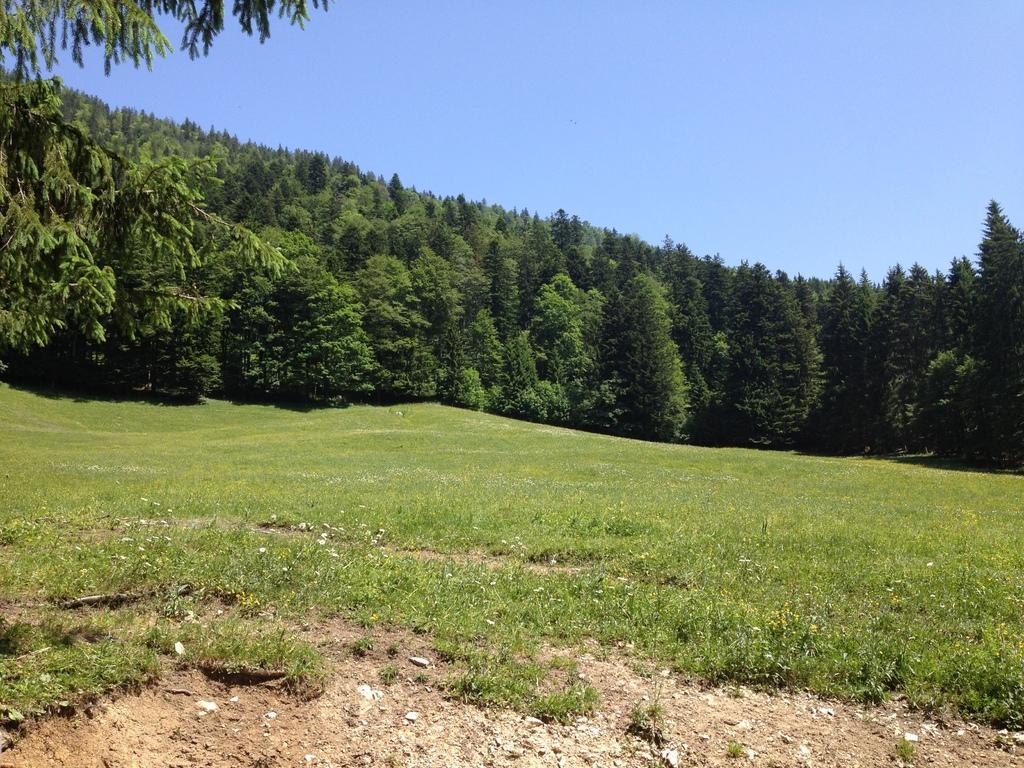What type of vegetation is on the ground in the image? There is grass present on the ground in the image. What can be seen in the background of the image? There are trees in the background of the image. What color is the sky in the image? The sky is blue in the image. What type of lace is draped over the trees in the image? There is no lace present in the image; it features grass, trees, and a blue sky. What type of feast is being prepared in the image? There is no feast or preparation for a feast visible in the image. 